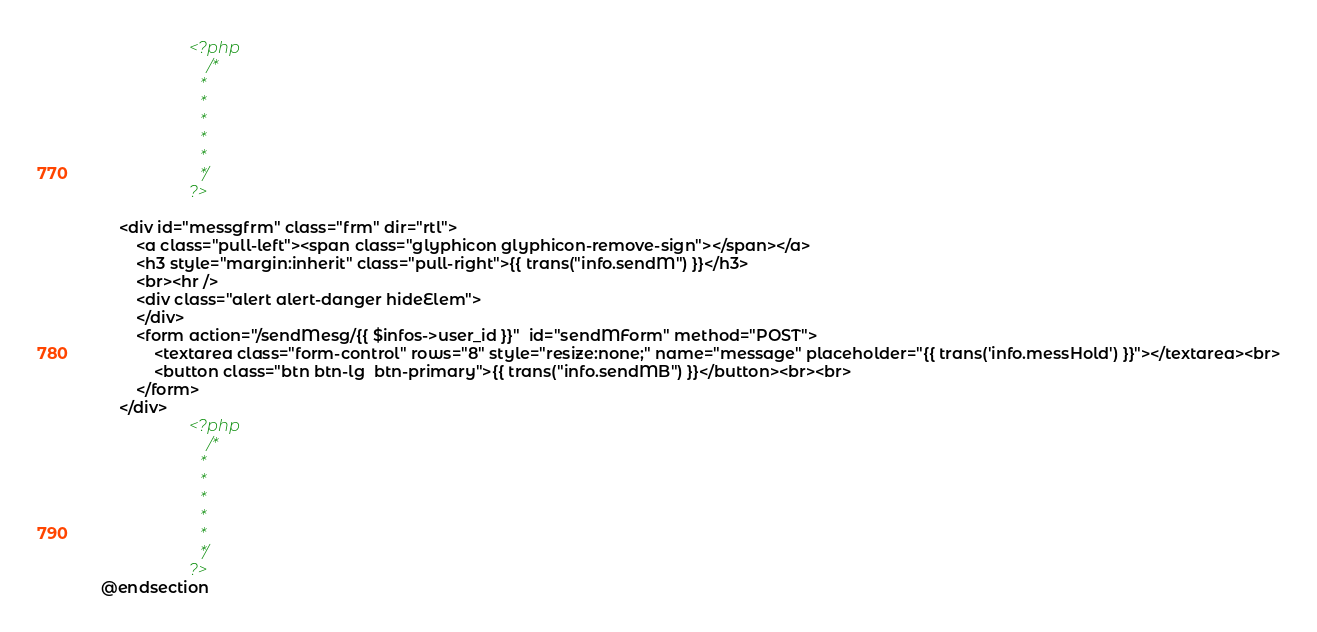<code> <loc_0><loc_0><loc_500><loc_500><_PHP_>					<?php 
						/*
						*
						*
						*
						*
						*
						*/
					?>	
		
	<div id="messgfrm" class="frm" dir="rtl">
		<a class="pull-left"><span class="glyphicon glyphicon-remove-sign"></span></a>
		<h3 style="margin:inherit" class="pull-right">{{ trans("info.sendM") }}</h3>
		<br><hr />
		<div class="alert alert-danger hideElem">
		</div>	
		<form action="/sendMesg/{{ $infos->user_id }}"  id="sendMForm" method="POST">
			<textarea class="form-control" rows="8" style="resize:none;" name="message" placeholder="{{ trans('info.messHold') }}"></textarea><br>
			<button class="btn btn-lg  btn-primary">{{ trans("info.sendMB") }}</button><br><br>
		</form>
	</div>
					<?php 
						/*
						*
						*
						*
						*
						*
						*/
					?>	
@endsection


</code> 